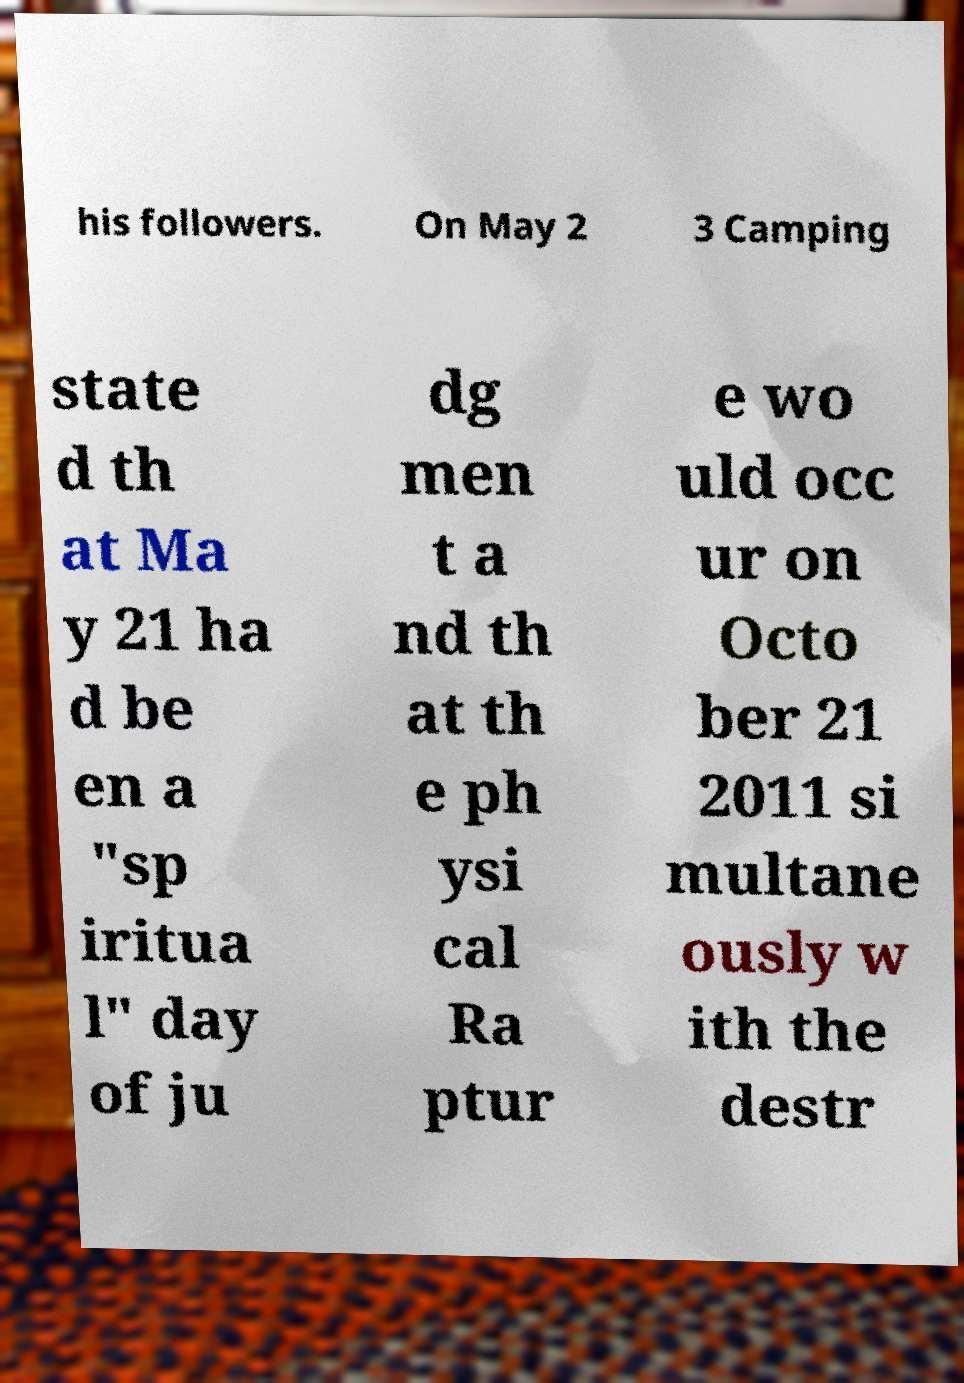Please identify and transcribe the text found in this image. his followers. On May 2 3 Camping state d th at Ma y 21 ha d be en a "sp iritua l" day of ju dg men t a nd th at th e ph ysi cal Ra ptur e wo uld occ ur on Octo ber 21 2011 si multane ously w ith the destr 